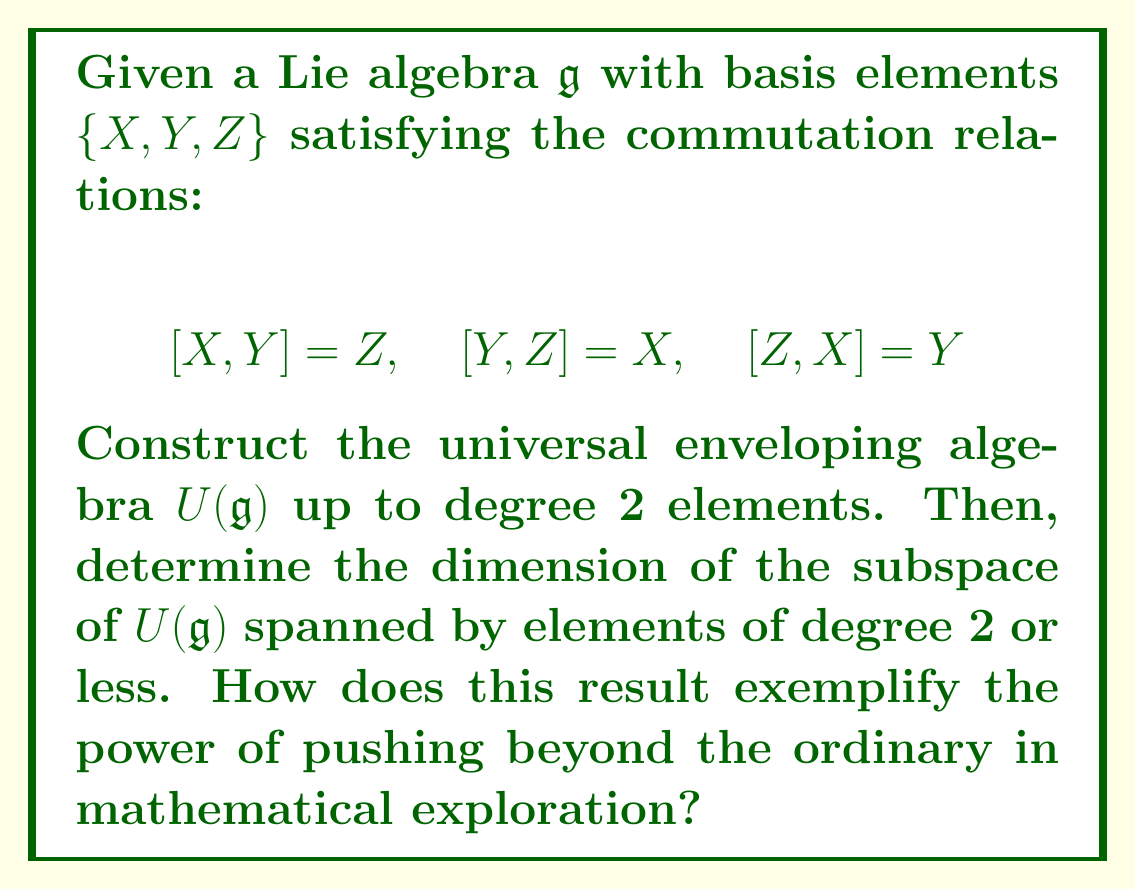Show me your answer to this math problem. To construct the universal enveloping algebra $U(\mathfrak{g})$ and determine its dimension up to degree 2, we'll follow these steps:

1) Start with the tensor algebra $T(\mathfrak{g})$, which includes all possible products of the basis elements.

2) Impose the relations from the Lie bracket in $\mathfrak{g}$ to obtain $U(\mathfrak{g})$.

3) Use the Poincaré-Birkhoff-Witt (PBW) theorem to organize the basis of $U(\mathfrak{g})$.

Step 1: Elements of $T(\mathfrak{g})$ up to degree 2:
- Degree 0: $1$ (the unit element)
- Degree 1: $X, Y, Z$
- Degree 2: $XX, XY, XZ, YX, YY, YZ, ZX, ZY, ZZ$

Step 2: Impose the Lie bracket relations:
$XY - YX = Z$
$YZ - ZY = X$
$ZX - XZ = Y$

These relations allow us to express $YX, ZY,$ and $XZ$ in terms of other elements.

Step 3: Apply the PBW theorem:
We can choose an ordering of the basis elements, say $X < Y < Z$. Then, a basis for $U(\mathfrak{g})$ up to degree 2 is:

- Degree 0: $1$
- Degree 1: $X, Y, Z$
- Degree 2: $XX, XY, XZ, YY, YZ, ZZ$

To determine the dimension, we count the basis elements:
- 1 element of degree 0
- 3 elements of degree 1
- 6 elements of degree 2

Total dimension: $1 + 3 + 6 = 10$

This result exemplifies the power of pushing beyond the ordinary by showing how the seemingly simple structure of a 3-dimensional Lie algebra expands into a rich 10-dimensional space when we consider its universal enveloping algebra. This expansion allows for a deeper understanding of the algebra's representations and provides a concrete manifestation of the abstract concept of "lifting" a Lie algebra to an associative algebra.
Answer: The dimension of the subspace of $U(\mathfrak{g})$ spanned by elements of degree 2 or less is 10. 